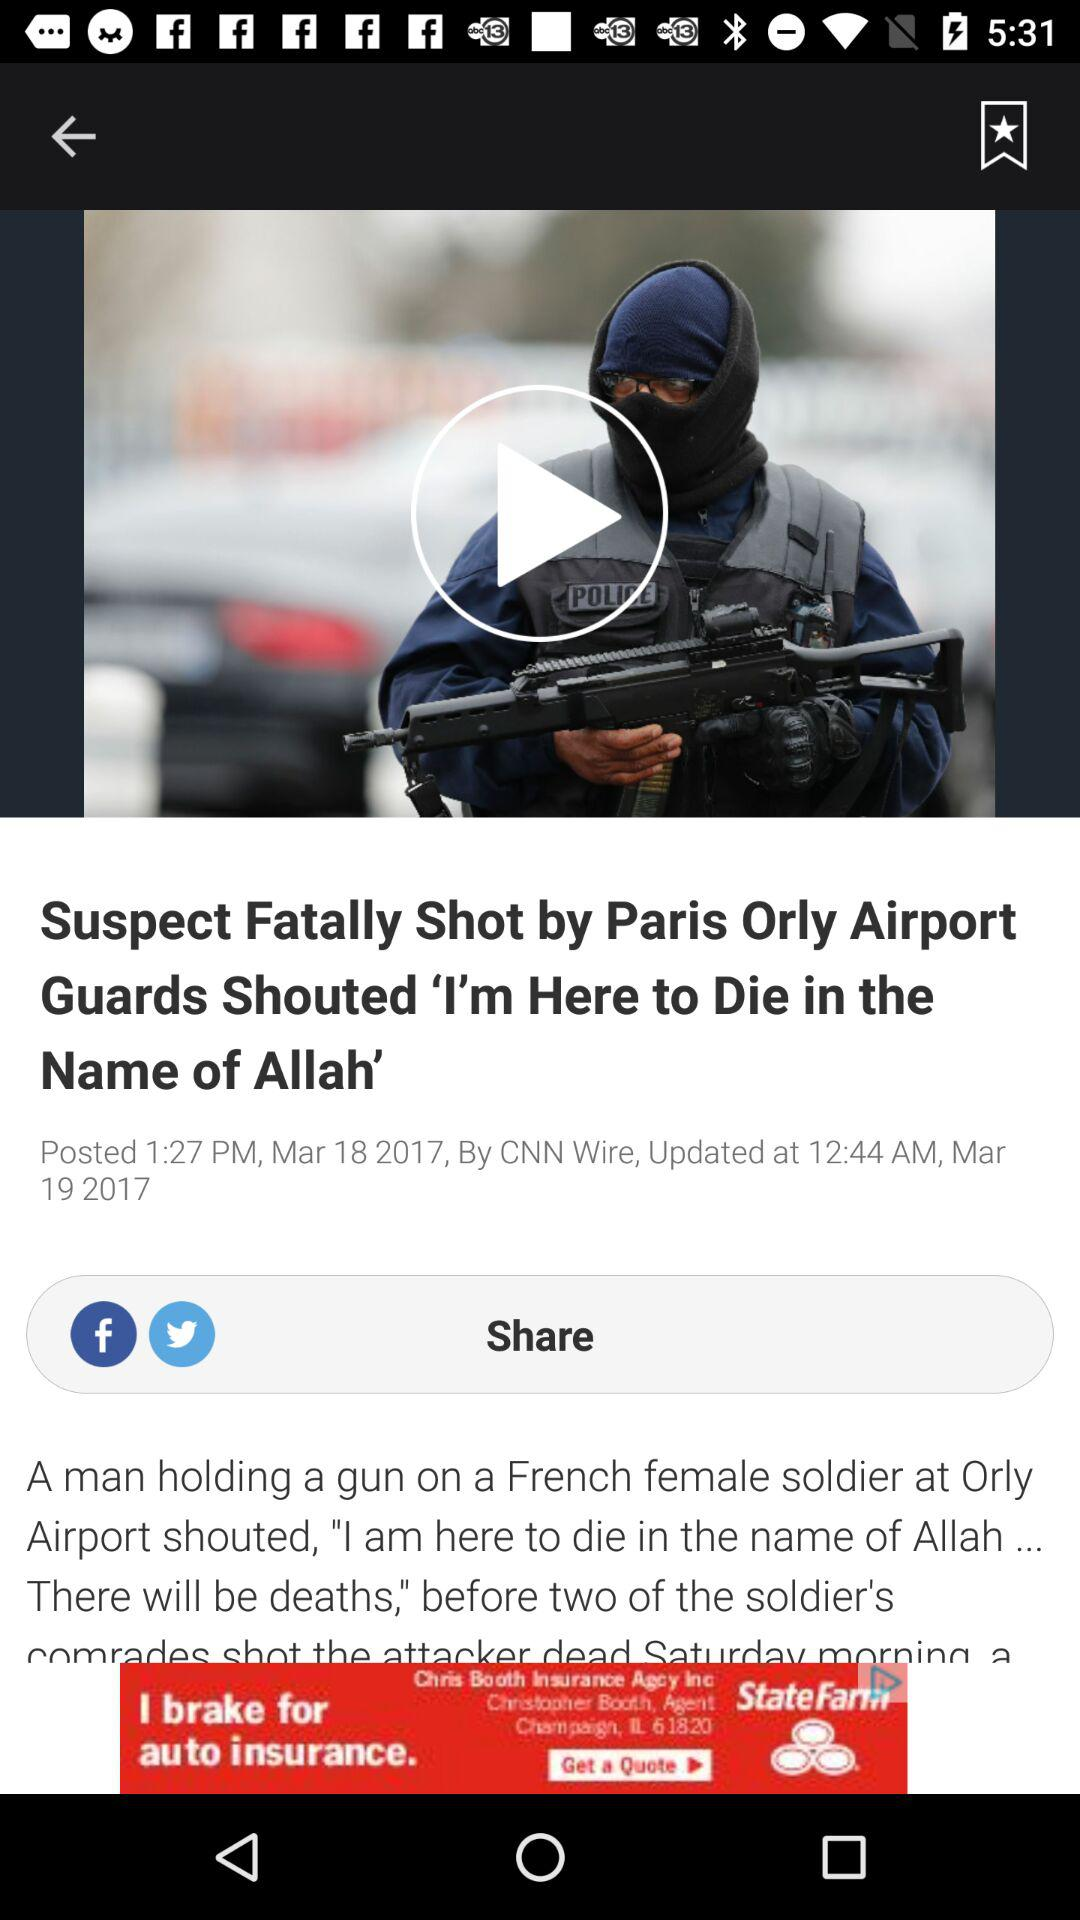What is the name of the article's author?
When the provided information is insufficient, respond with <no answer>. <no answer> 